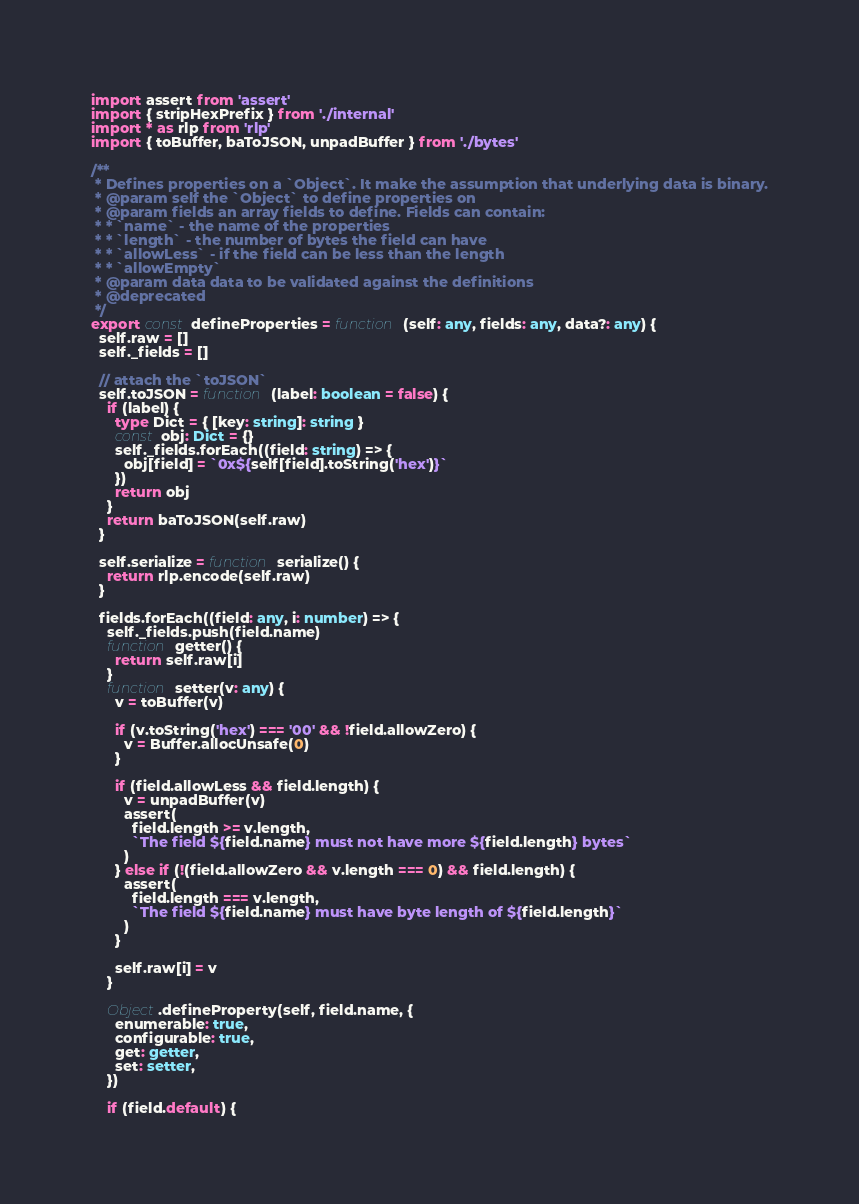Convert code to text. <code><loc_0><loc_0><loc_500><loc_500><_TypeScript_>import assert from 'assert'
import { stripHexPrefix } from './internal'
import * as rlp from 'rlp'
import { toBuffer, baToJSON, unpadBuffer } from './bytes'

/**
 * Defines properties on a `Object`. It make the assumption that underlying data is binary.
 * @param self the `Object` to define properties on
 * @param fields an array fields to define. Fields can contain:
 * * `name` - the name of the properties
 * * `length` - the number of bytes the field can have
 * * `allowLess` - if the field can be less than the length
 * * `allowEmpty`
 * @param data data to be validated against the definitions
 * @deprecated
 */
export const defineProperties = function (self: any, fields: any, data?: any) {
  self.raw = []
  self._fields = []

  // attach the `toJSON`
  self.toJSON = function (label: boolean = false) {
    if (label) {
      type Dict = { [key: string]: string }
      const obj: Dict = {}
      self._fields.forEach((field: string) => {
        obj[field] = `0x${self[field].toString('hex')}`
      })
      return obj
    }
    return baToJSON(self.raw)
  }

  self.serialize = function serialize() {
    return rlp.encode(self.raw)
  }

  fields.forEach((field: any, i: number) => {
    self._fields.push(field.name)
    function getter() {
      return self.raw[i]
    }
    function setter(v: any) {
      v = toBuffer(v)

      if (v.toString('hex') === '00' && !field.allowZero) {
        v = Buffer.allocUnsafe(0)
      }

      if (field.allowLess && field.length) {
        v = unpadBuffer(v)
        assert(
          field.length >= v.length,
          `The field ${field.name} must not have more ${field.length} bytes`
        )
      } else if (!(field.allowZero && v.length === 0) && field.length) {
        assert(
          field.length === v.length,
          `The field ${field.name} must have byte length of ${field.length}`
        )
      }

      self.raw[i] = v
    }

    Object.defineProperty(self, field.name, {
      enumerable: true,
      configurable: true,
      get: getter,
      set: setter,
    })

    if (field.default) {</code> 